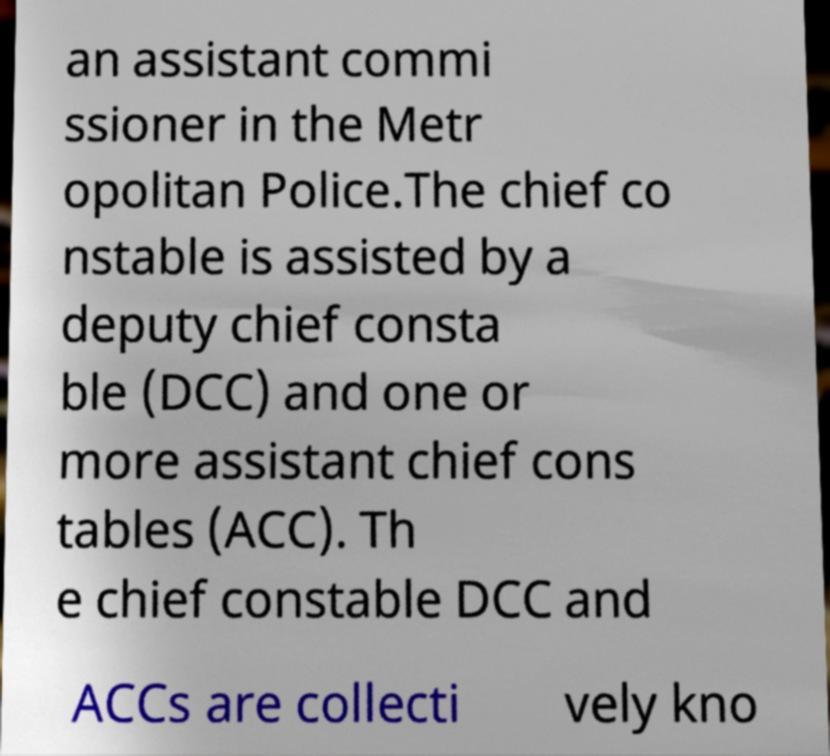Can you accurately transcribe the text from the provided image for me? an assistant commi ssioner in the Metr opolitan Police.The chief co nstable is assisted by a deputy chief consta ble (DCC) and one or more assistant chief cons tables (ACC). Th e chief constable DCC and ACCs are collecti vely kno 